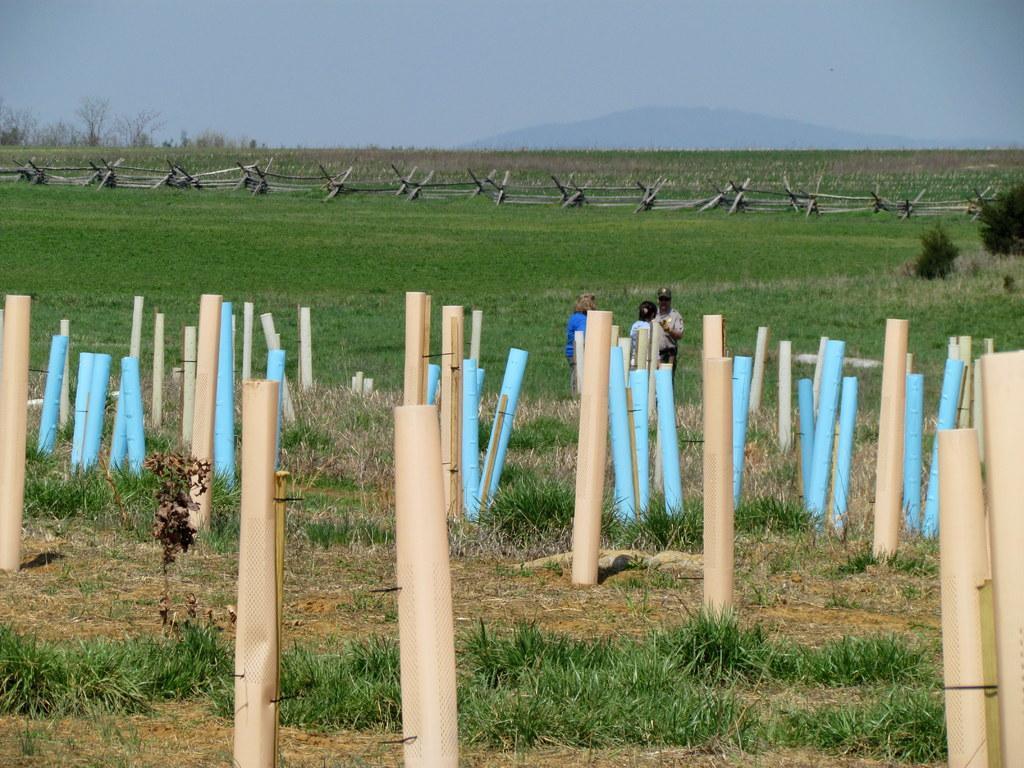Please provide a concise description of this image. We can see cream and blue color poles and we can see grass. There are people standing. Background we can see trees,hill and sky. 